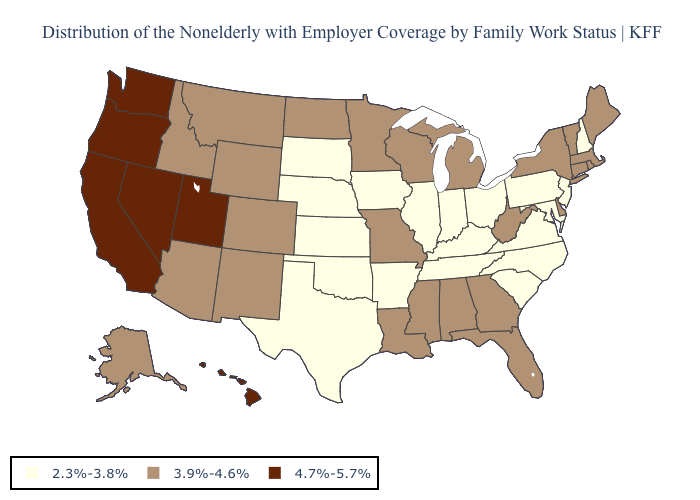Does Oregon have the highest value in the USA?
Quick response, please. Yes. How many symbols are there in the legend?
Give a very brief answer. 3. Name the states that have a value in the range 2.3%-3.8%?
Write a very short answer. Arkansas, Illinois, Indiana, Iowa, Kansas, Kentucky, Maryland, Nebraska, New Hampshire, New Jersey, North Carolina, Ohio, Oklahoma, Pennsylvania, South Carolina, South Dakota, Tennessee, Texas, Virginia. Does the map have missing data?
Concise answer only. No. Name the states that have a value in the range 4.7%-5.7%?
Concise answer only. California, Hawaii, Nevada, Oregon, Utah, Washington. Does North Dakota have the lowest value in the MidWest?
Write a very short answer. No. Among the states that border North Carolina , does Georgia have the lowest value?
Quick response, please. No. Does the first symbol in the legend represent the smallest category?
Keep it brief. Yes. Name the states that have a value in the range 3.9%-4.6%?
Give a very brief answer. Alabama, Alaska, Arizona, Colorado, Connecticut, Delaware, Florida, Georgia, Idaho, Louisiana, Maine, Massachusetts, Michigan, Minnesota, Mississippi, Missouri, Montana, New Mexico, New York, North Dakota, Rhode Island, Vermont, West Virginia, Wisconsin, Wyoming. Does Rhode Island have a higher value than Texas?
Quick response, please. Yes. What is the value of North Carolina?
Keep it brief. 2.3%-3.8%. Does the map have missing data?
Concise answer only. No. Does New Jersey have the highest value in the USA?
Be succinct. No. What is the highest value in states that border Ohio?
Quick response, please. 3.9%-4.6%. 